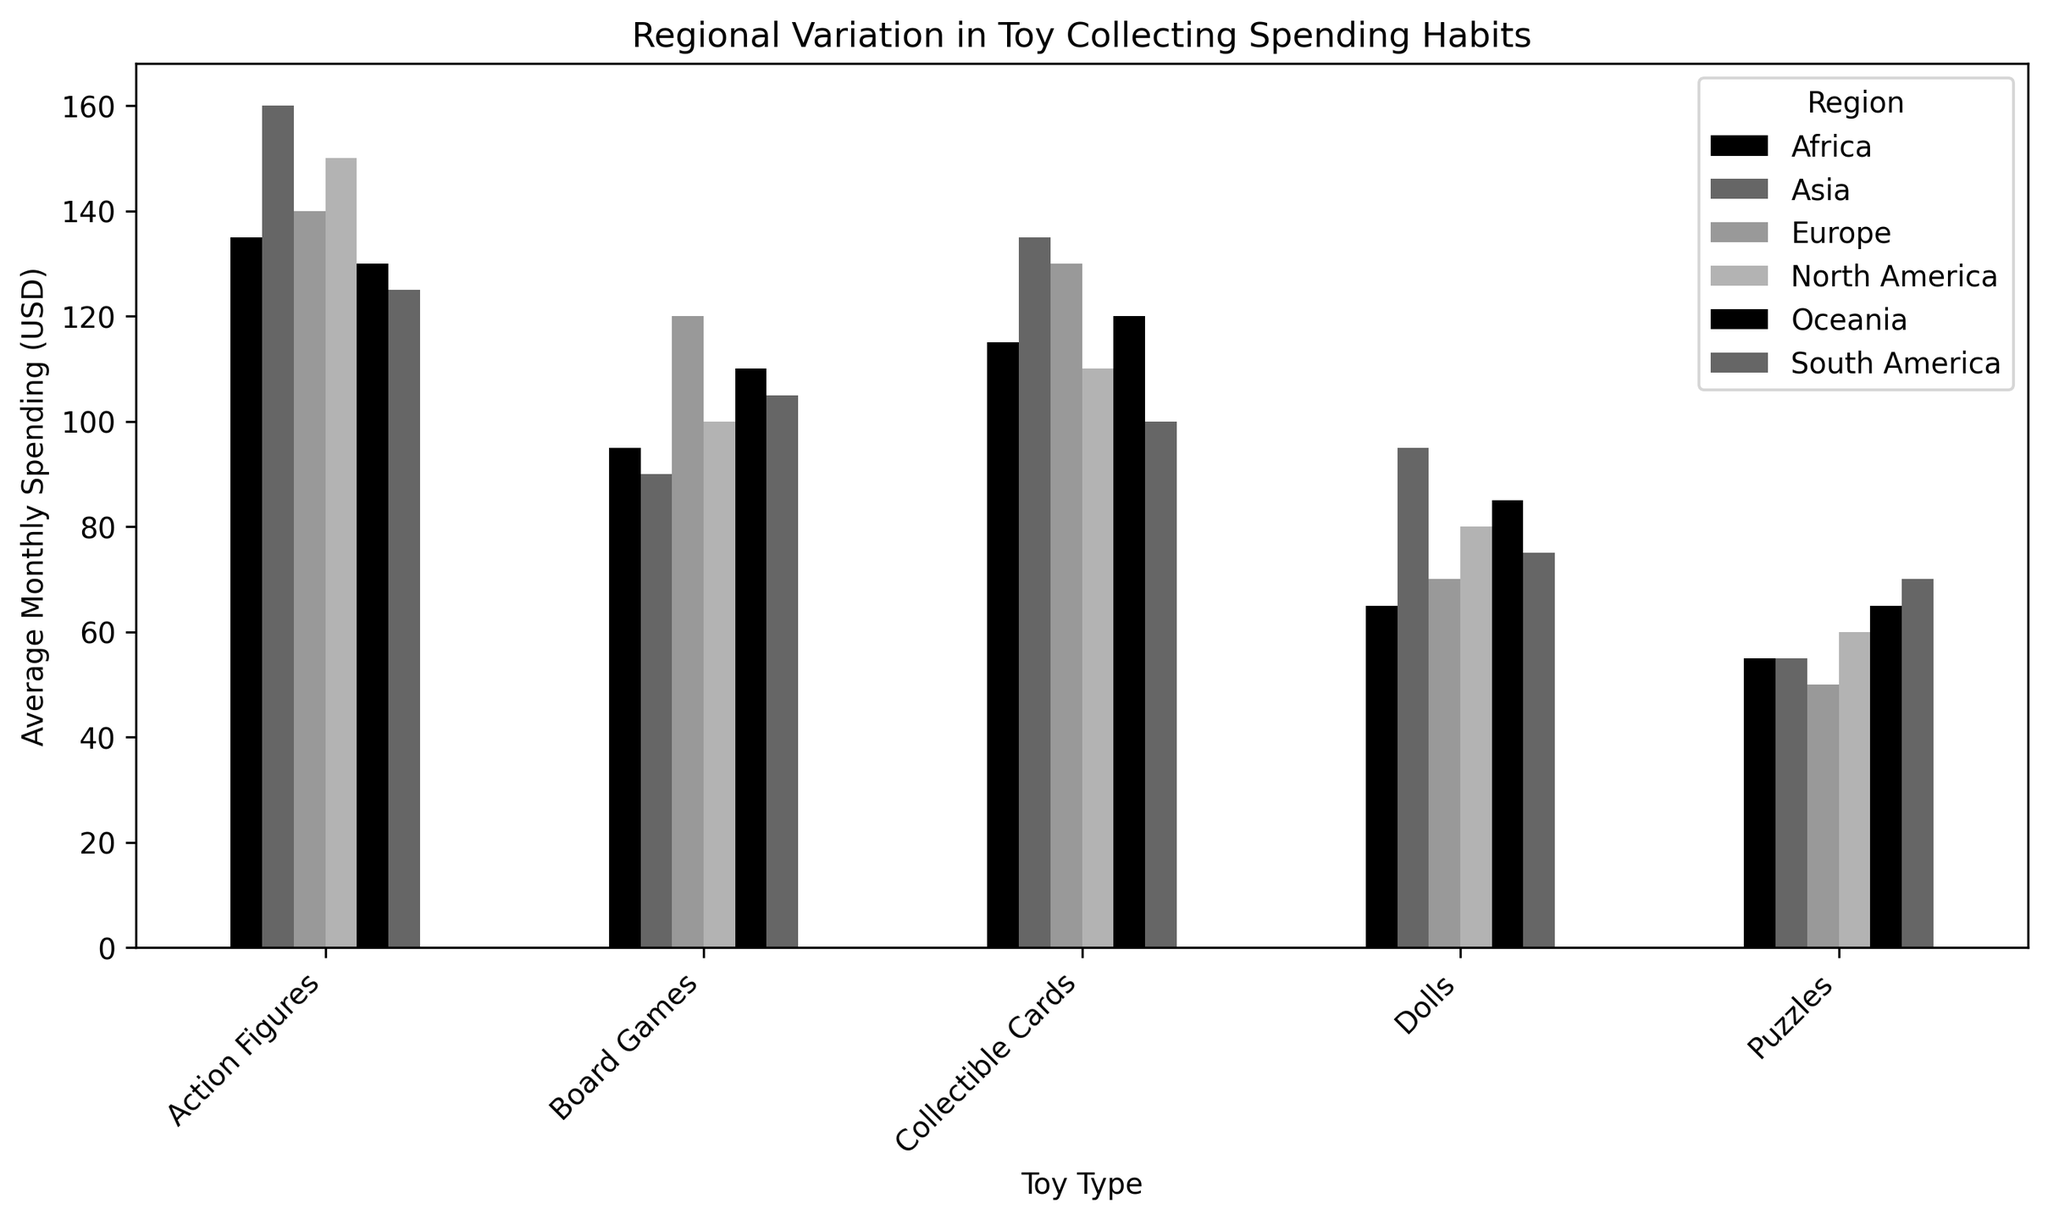Which region spends the most on action figures? Look at the heights of the bars in the "Action Figures" category. The tallest bar represents the highest spending.
Answer: Asia Which region spends the least on puzzles? Look at the bars corresponding to "Puzzles" for each region. The shortest bar will represent the lowest spending.
Answer: Europe What is the difference in average monthly spending on dolls between North America and Asia? Find the heights of the bars for "Dolls" in North America and Asia and subtract the lower value from the higher value.
Answer: 15 USD Which toy type has the highest average monthly spending in Oceania? Look at the heights of all the bars under the Oceania category. The tallest bar indicates the highest spending.
Answer: Collectible Cards What is the sum of the average monthly spending on board games in North America and Europe? Locate and add up the heights of the bars for "Board Games" in North America and Europe.
Answer: 220 USD How does the average spending on collectible cards in Africa compare to Oceania? Compare the heights of the bars for "Collectible Cards" between Africa and Oceania directly.
Answer: Africa spends more Which toy type has the greatest variation in spending among all the regions? Compare the range of heights of all bars across different toy types.
Answer: Collectible Cards What is the average of the average monthly spending on dolls across all regions? Add up the heights of the bars corresponding to "Dolls" in each region and divide by the number of regions (6).
Answer: 78.33 USD Is the spending on board games in Africa greater than in Asia? Compare the heights of the bars for "Board Games" in Africa and Asia directly.
Answer: No 